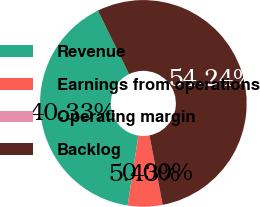Convert chart to OTSL. <chart><loc_0><loc_0><loc_500><loc_500><pie_chart><fcel>Revenue<fcel>Earnings from operations<fcel>Operating margin<fcel>Backlog<nl><fcel>40.33%<fcel>5.43%<fcel>0.0%<fcel>54.24%<nl></chart> 